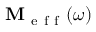<formula> <loc_0><loc_0><loc_500><loc_500>M _ { e f f } ( \omega )</formula> 